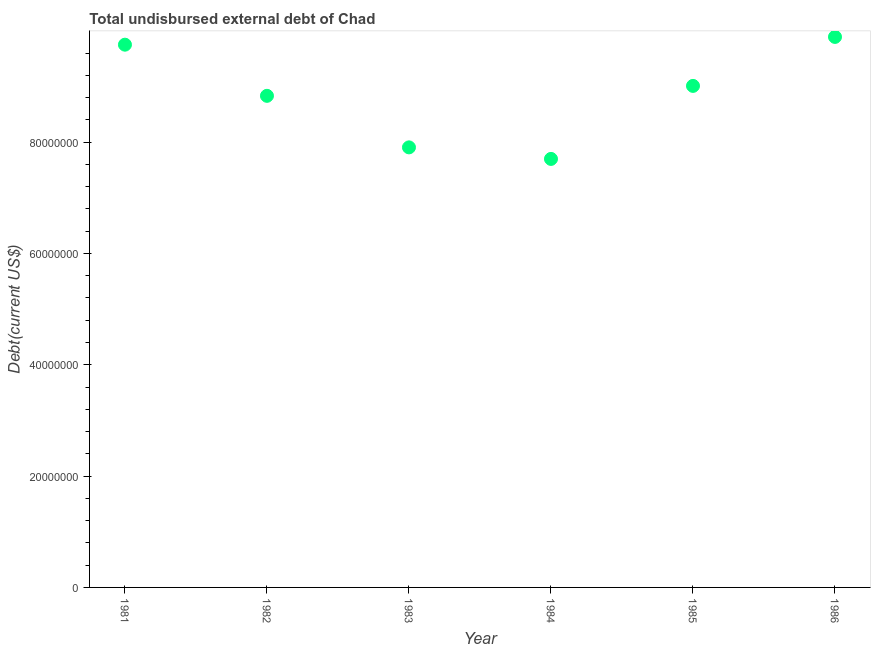What is the total debt in 1983?
Provide a short and direct response. 7.91e+07. Across all years, what is the maximum total debt?
Your answer should be compact. 9.89e+07. Across all years, what is the minimum total debt?
Offer a terse response. 7.70e+07. What is the sum of the total debt?
Make the answer very short. 5.31e+08. What is the difference between the total debt in 1984 and 1986?
Your answer should be very brief. -2.19e+07. What is the average total debt per year?
Keep it short and to the point. 8.85e+07. What is the median total debt?
Provide a short and direct response. 8.92e+07. In how many years, is the total debt greater than 88000000 US$?
Make the answer very short. 4. Do a majority of the years between 1982 and 1985 (inclusive) have total debt greater than 24000000 US$?
Make the answer very short. Yes. What is the ratio of the total debt in 1984 to that in 1985?
Provide a short and direct response. 0.85. What is the difference between the highest and the second highest total debt?
Provide a short and direct response. 1.39e+06. Is the sum of the total debt in 1983 and 1986 greater than the maximum total debt across all years?
Your response must be concise. Yes. What is the difference between the highest and the lowest total debt?
Your answer should be compact. 2.19e+07. In how many years, is the total debt greater than the average total debt taken over all years?
Provide a short and direct response. 3. Does the total debt monotonically increase over the years?
Make the answer very short. No. How many dotlines are there?
Your answer should be very brief. 1. What is the difference between two consecutive major ticks on the Y-axis?
Your response must be concise. 2.00e+07. Are the values on the major ticks of Y-axis written in scientific E-notation?
Offer a very short reply. No. Does the graph contain any zero values?
Offer a terse response. No. Does the graph contain grids?
Provide a short and direct response. No. What is the title of the graph?
Provide a succinct answer. Total undisbursed external debt of Chad. What is the label or title of the X-axis?
Offer a terse response. Year. What is the label or title of the Y-axis?
Your answer should be compact. Debt(current US$). What is the Debt(current US$) in 1981?
Your response must be concise. 9.75e+07. What is the Debt(current US$) in 1982?
Your answer should be compact. 8.83e+07. What is the Debt(current US$) in 1983?
Your response must be concise. 7.91e+07. What is the Debt(current US$) in 1984?
Offer a terse response. 7.70e+07. What is the Debt(current US$) in 1985?
Provide a short and direct response. 9.01e+07. What is the Debt(current US$) in 1986?
Make the answer very short. 9.89e+07. What is the difference between the Debt(current US$) in 1981 and 1982?
Offer a very short reply. 9.19e+06. What is the difference between the Debt(current US$) in 1981 and 1983?
Your answer should be very brief. 1.84e+07. What is the difference between the Debt(current US$) in 1981 and 1984?
Give a very brief answer. 2.05e+07. What is the difference between the Debt(current US$) in 1981 and 1985?
Provide a succinct answer. 7.40e+06. What is the difference between the Debt(current US$) in 1981 and 1986?
Your answer should be compact. -1.39e+06. What is the difference between the Debt(current US$) in 1982 and 1983?
Make the answer very short. 9.26e+06. What is the difference between the Debt(current US$) in 1982 and 1984?
Your answer should be very brief. 1.13e+07. What is the difference between the Debt(current US$) in 1982 and 1985?
Keep it short and to the point. -1.78e+06. What is the difference between the Debt(current US$) in 1982 and 1986?
Your answer should be very brief. -1.06e+07. What is the difference between the Debt(current US$) in 1983 and 1984?
Provide a succinct answer. 2.07e+06. What is the difference between the Debt(current US$) in 1983 and 1985?
Make the answer very short. -1.10e+07. What is the difference between the Debt(current US$) in 1983 and 1986?
Make the answer very short. -1.98e+07. What is the difference between the Debt(current US$) in 1984 and 1985?
Offer a terse response. -1.31e+07. What is the difference between the Debt(current US$) in 1984 and 1986?
Give a very brief answer. -2.19e+07. What is the difference between the Debt(current US$) in 1985 and 1986?
Offer a very short reply. -8.80e+06. What is the ratio of the Debt(current US$) in 1981 to that in 1982?
Keep it short and to the point. 1.1. What is the ratio of the Debt(current US$) in 1981 to that in 1983?
Offer a terse response. 1.23. What is the ratio of the Debt(current US$) in 1981 to that in 1984?
Provide a succinct answer. 1.27. What is the ratio of the Debt(current US$) in 1981 to that in 1985?
Your answer should be very brief. 1.08. What is the ratio of the Debt(current US$) in 1981 to that in 1986?
Your response must be concise. 0.99. What is the ratio of the Debt(current US$) in 1982 to that in 1983?
Offer a very short reply. 1.12. What is the ratio of the Debt(current US$) in 1982 to that in 1984?
Your response must be concise. 1.15. What is the ratio of the Debt(current US$) in 1982 to that in 1985?
Your answer should be compact. 0.98. What is the ratio of the Debt(current US$) in 1982 to that in 1986?
Offer a terse response. 0.89. What is the ratio of the Debt(current US$) in 1983 to that in 1985?
Keep it short and to the point. 0.88. What is the ratio of the Debt(current US$) in 1983 to that in 1986?
Your answer should be compact. 0.8. What is the ratio of the Debt(current US$) in 1984 to that in 1985?
Offer a very short reply. 0.85. What is the ratio of the Debt(current US$) in 1984 to that in 1986?
Provide a succinct answer. 0.78. What is the ratio of the Debt(current US$) in 1985 to that in 1986?
Provide a short and direct response. 0.91. 